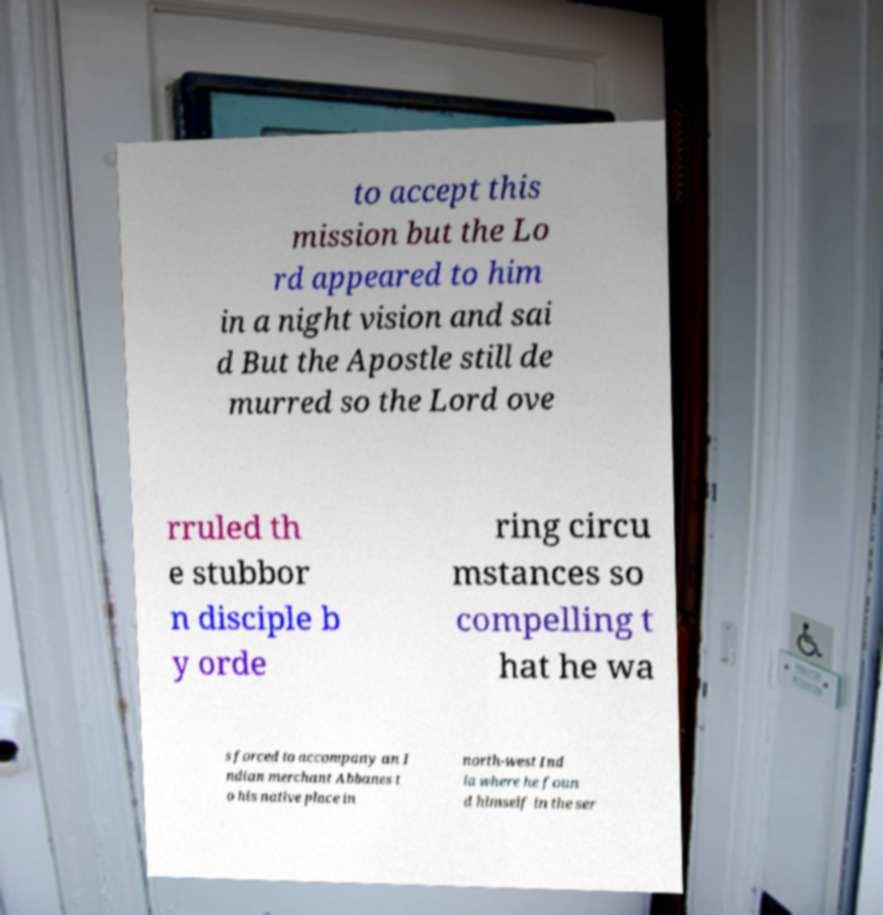Can you read and provide the text displayed in the image?This photo seems to have some interesting text. Can you extract and type it out for me? to accept this mission but the Lo rd appeared to him in a night vision and sai d But the Apostle still de murred so the Lord ove rruled th e stubbor n disciple b y orde ring circu mstances so compelling t hat he wa s forced to accompany an I ndian merchant Abbanes t o his native place in north-west Ind ia where he foun d himself in the ser 